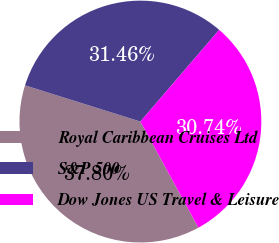Convert chart. <chart><loc_0><loc_0><loc_500><loc_500><pie_chart><fcel>Royal Caribbean Cruises Ltd<fcel>S&P 500<fcel>Dow Jones US Travel & Leisure<nl><fcel>37.8%<fcel>31.46%<fcel>30.74%<nl></chart> 